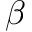Convert formula to latex. <formula><loc_0><loc_0><loc_500><loc_500>\beta</formula> 